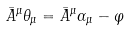Convert formula to latex. <formula><loc_0><loc_0><loc_500><loc_500>\bar { A } ^ { \mu } \theta _ { \mu } = \bar { A } ^ { \mu } \alpha _ { \mu } - \varphi</formula> 